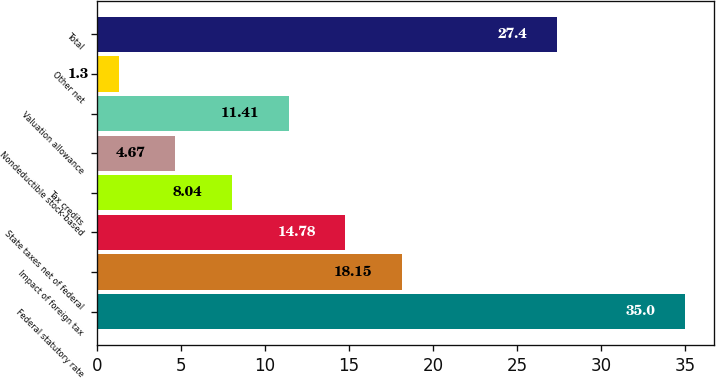Convert chart to OTSL. <chart><loc_0><loc_0><loc_500><loc_500><bar_chart><fcel>Federal statutory rate<fcel>Impact of foreign tax<fcel>State taxes net of federal<fcel>Tax credits<fcel>Nondeductible stock-based<fcel>Valuation allowance<fcel>Other net<fcel>Total<nl><fcel>35<fcel>18.15<fcel>14.78<fcel>8.04<fcel>4.67<fcel>11.41<fcel>1.3<fcel>27.4<nl></chart> 